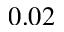Convert formula to latex. <formula><loc_0><loc_0><loc_500><loc_500>0 . 0 2</formula> 